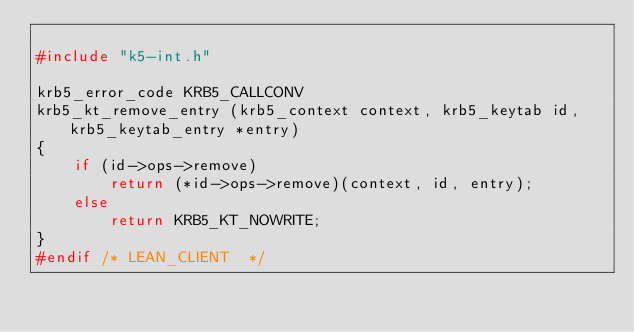<code> <loc_0><loc_0><loc_500><loc_500><_C_>
#include "k5-int.h"

krb5_error_code KRB5_CALLCONV
krb5_kt_remove_entry (krb5_context context, krb5_keytab id, krb5_keytab_entry *entry)
{
    if (id->ops->remove)
        return (*id->ops->remove)(context, id, entry);
    else
        return KRB5_KT_NOWRITE;
}
#endif /* LEAN_CLIENT  */
</code> 